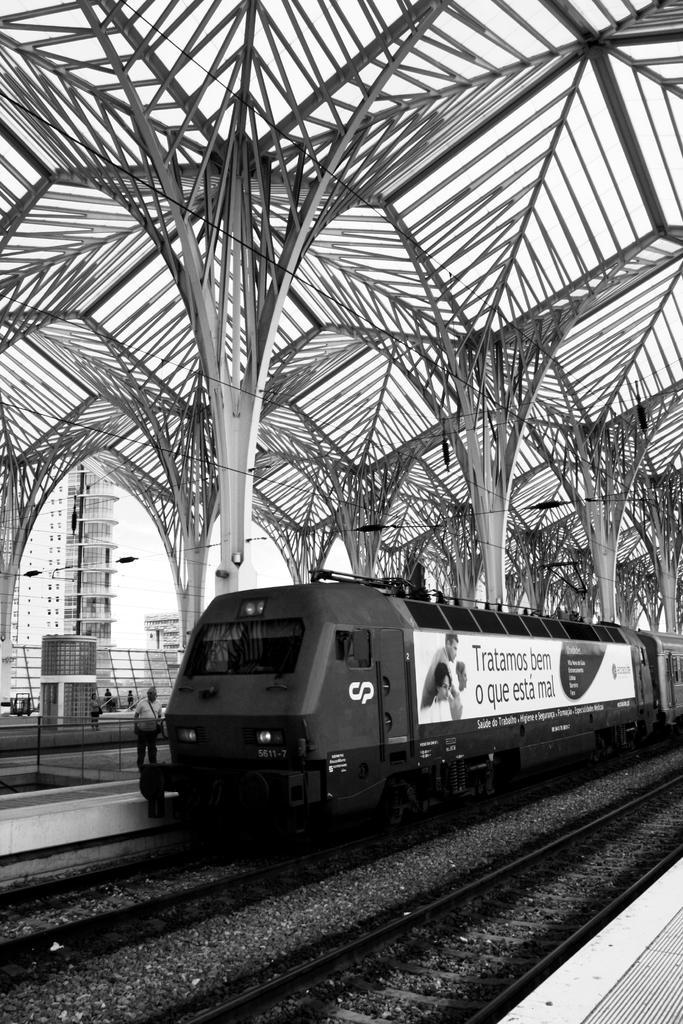Describe this image in one or two sentences. In this picture I can see a train on the track, side we can see people standing and also we can see some buildings, iron fencing which is in the shapes of tree. 